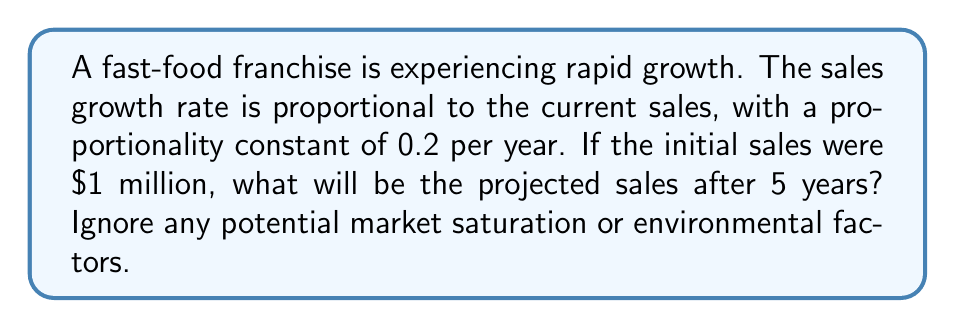Could you help me with this problem? To solve this problem, we'll use a simple exponential growth model, which is a basic form of time series analysis using differential equations.

1. Let $S(t)$ be the sales (in millions) at time $t$ (in years).

2. The differential equation describing the growth is:

   $$\frac{dS}{dt} = 0.2S$$

3. This is a separable differential equation. We can solve it as follows:

   $$\frac{dS}{S} = 0.2dt$$

4. Integrating both sides:

   $$\int \frac{dS}{S} = \int 0.2dt$$
   $$\ln|S| = 0.2t + C$$

5. Using the initial condition $S(0) = 1$ (initial sales of $1 million), we can find $C$:

   $$\ln|1| = 0.2(0) + C$$
   $$0 = C$$

6. Therefore, the general solution is:

   $$\ln|S| = 0.2t$$
   $$S(t) = e^{0.2t}$$

7. To find the sales after 5 years, we substitute $t = 5$:

   $$S(5) = e^{0.2(5)} = e^1 \approx 2.718281828$$

8. Converting back to dollars:

   $2.718281828 million = $2,718,281.83
Answer: $2,718,281.83 